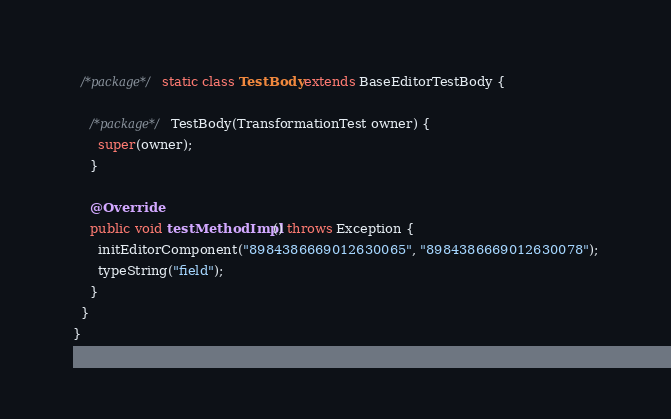<code> <loc_0><loc_0><loc_500><loc_500><_Java_>
  /*package*/ static class TestBody extends BaseEditorTestBody {

    /*package*/ TestBody(TransformationTest owner) {
      super(owner);
    }

    @Override
    public void testMethodImpl() throws Exception {
      initEditorComponent("8984386669012630065", "8984386669012630078");
      typeString("field");
    }
  }
}
</code> 